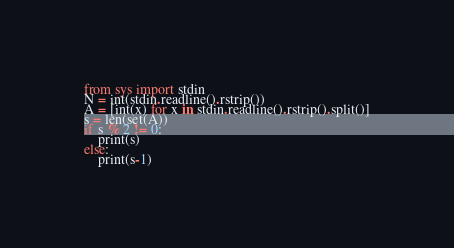<code> <loc_0><loc_0><loc_500><loc_500><_Python_>from sys import stdin
N = int(stdin.readline().rstrip())
A = [int(x) for x in stdin.readline().rstrip().split()]
s = len(set(A))
if s % 2 != 0:
    print(s)
else:
    print(s-1)</code> 